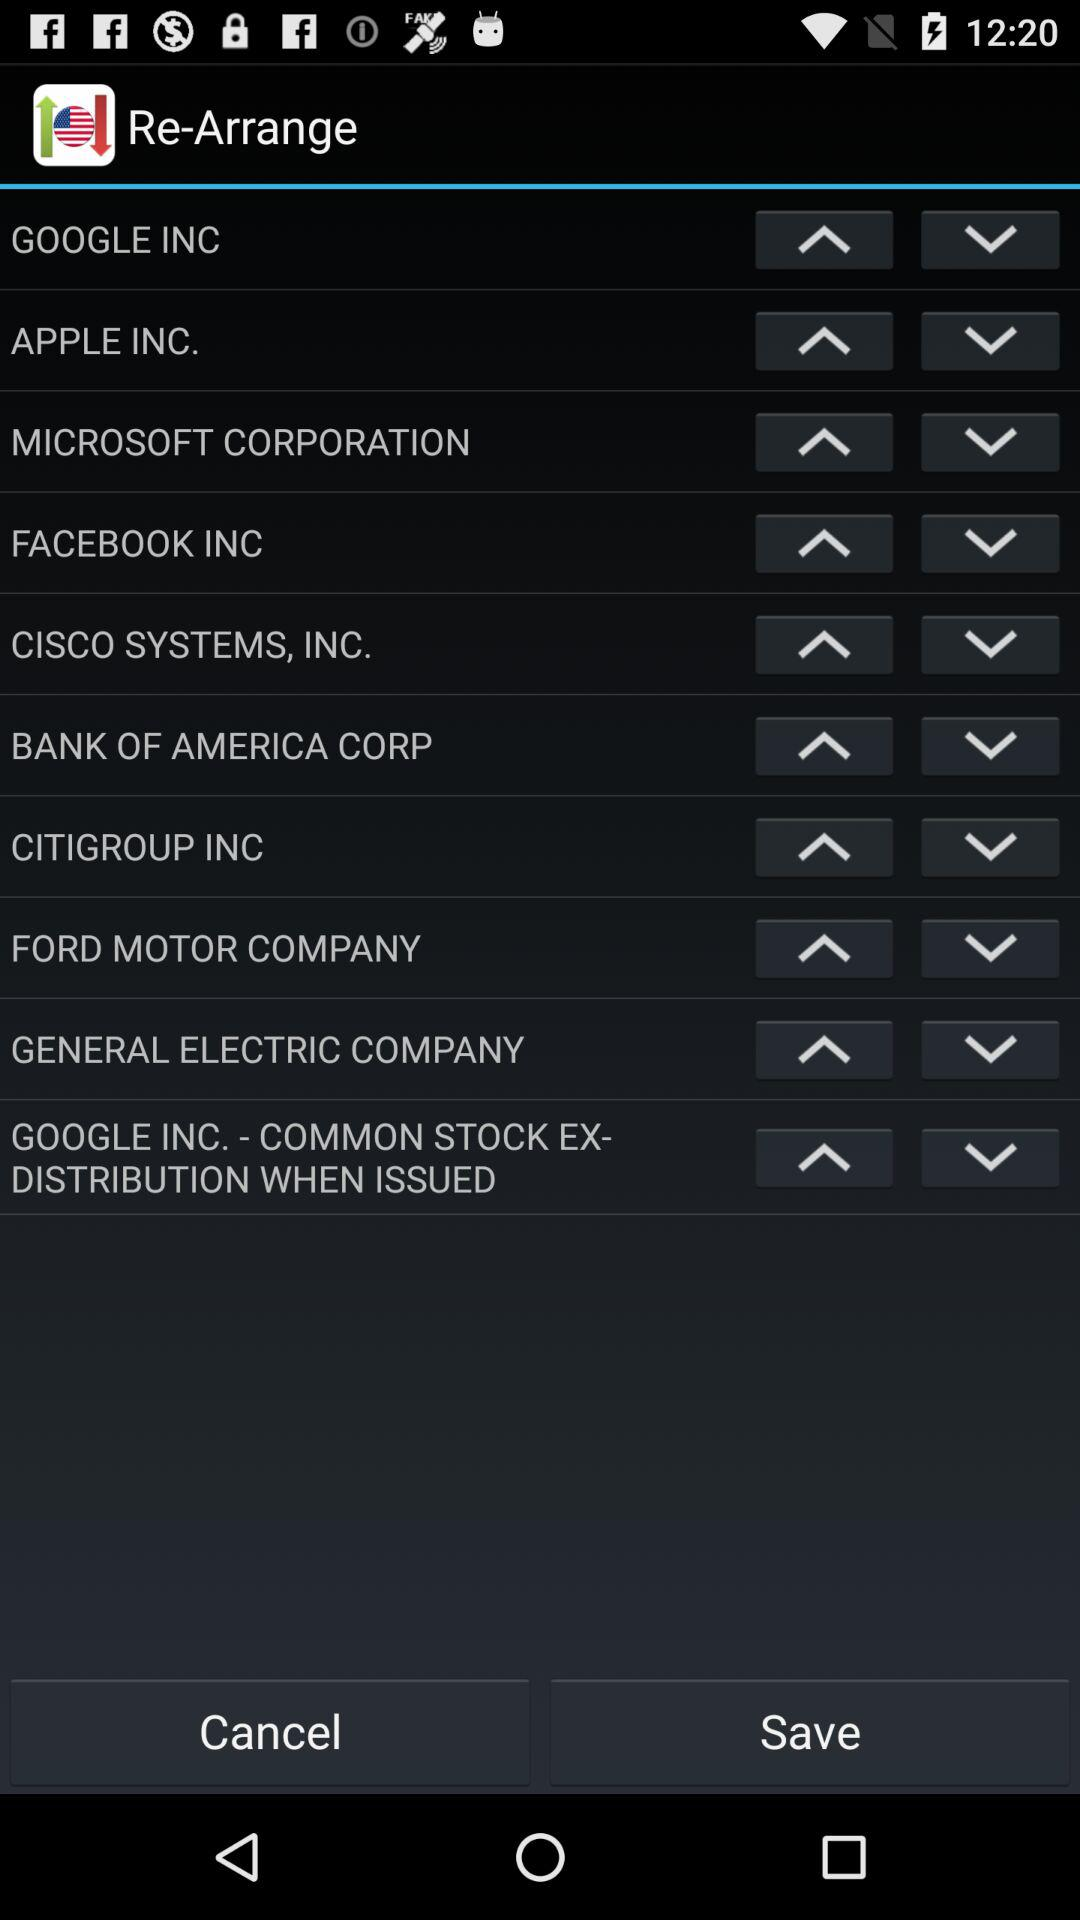What is the app name? The app name is "Re-Arrange". 